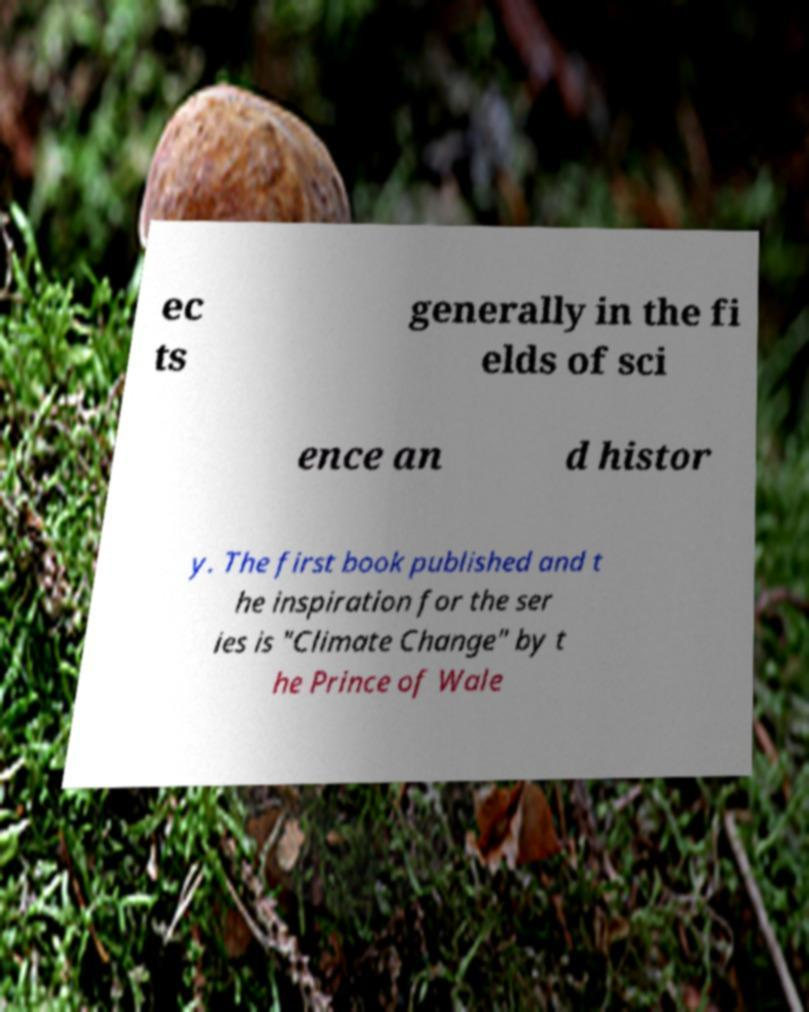Could you extract and type out the text from this image? ec ts generally in the fi elds of sci ence an d histor y. The first book published and t he inspiration for the ser ies is "Climate Change" by t he Prince of Wale 